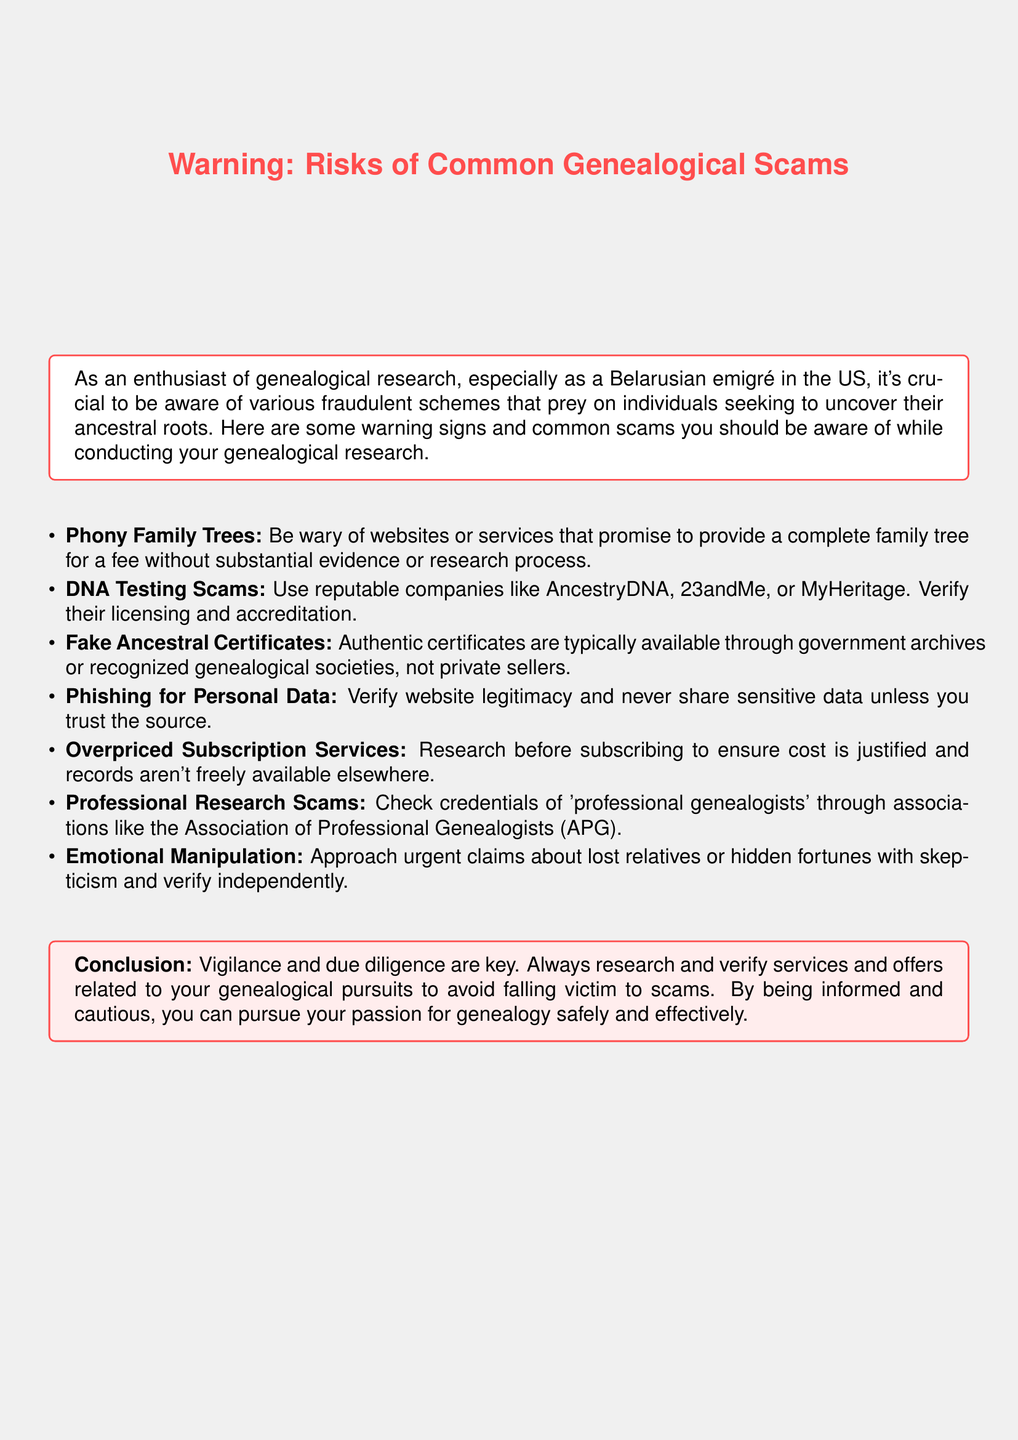What is the title of the document? The title is displayed prominently and indicates the main topic addressed in the document.
Answer: Warning: Risks of Common Genealogical Scams What should you verify when using DNA testing services? The document advises to check the licensing and accreditation of the companies.
Answer: Licensing and accreditation What type of scams related to genealogy does the document mention? The document lists different kinds of scams that target genealogical research enthusiasts, summarizing the risks involved.
Answer: Phony Family Trees, DNA Testing Scams, Fake Ancestral Certificates, Phishing for Personal Data, Overpriced Subscription Services, Professional Research Scams, Emotional Manipulation What organization can you check for professional genealogists' credentials? The document references a recognized association for validating genealogist credentials.
Answer: Association of Professional Genealogists (APG) What is emphasized as key to avoid scams? The conclusion of the document clearly states what is necessary to ensure safe genealogical research amidst scams.
Answer: Vigilance and due diligence Which color is used for the warning box? The color used in the warning box is a specific shade that highlights the cautionary nature of the content.
Answer: Warning red 